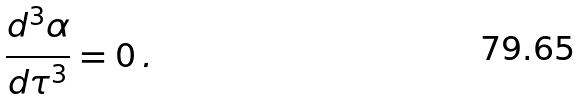Convert formula to latex. <formula><loc_0><loc_0><loc_500><loc_500>\frac { d ^ { 3 } \alpha } { d \tau ^ { 3 } } = 0 \, .</formula> 